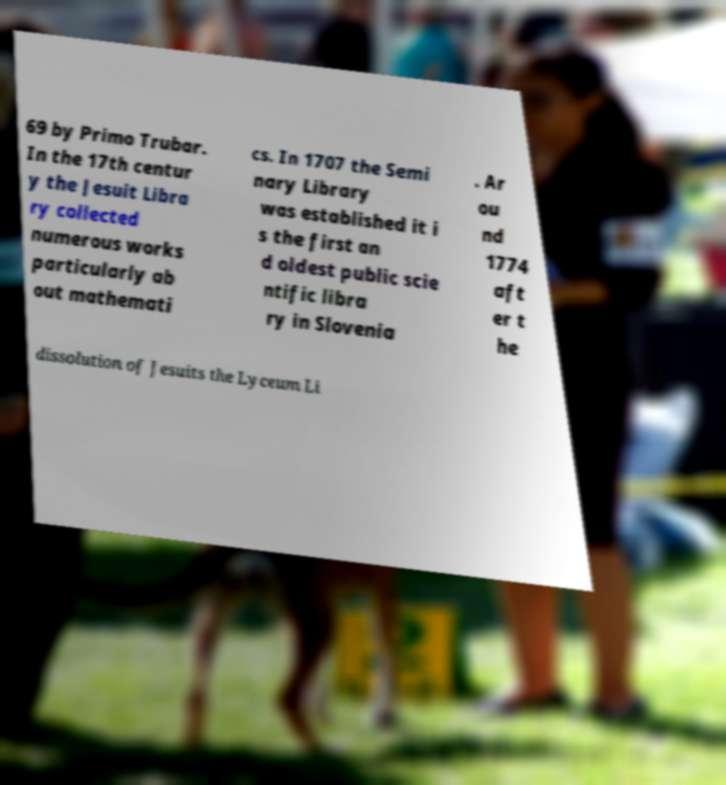There's text embedded in this image that I need extracted. Can you transcribe it verbatim? 69 by Primo Trubar. In the 17th centur y the Jesuit Libra ry collected numerous works particularly ab out mathemati cs. In 1707 the Semi nary Library was established it i s the first an d oldest public scie ntific libra ry in Slovenia . Ar ou nd 1774 aft er t he dissolution of Jesuits the Lyceum Li 